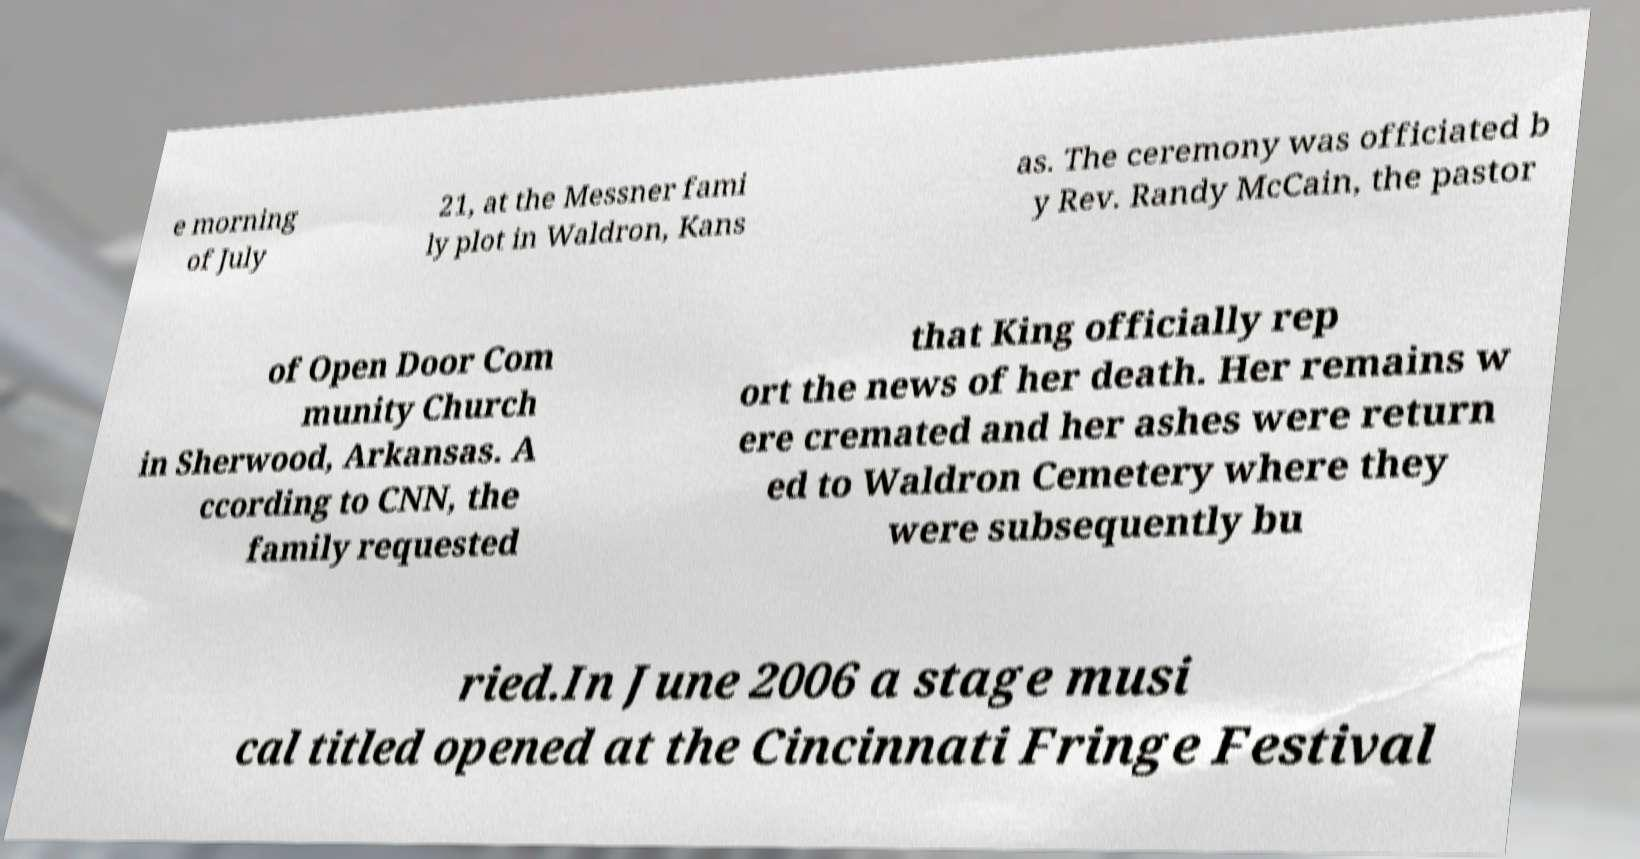Can you accurately transcribe the text from the provided image for me? e morning of July 21, at the Messner fami ly plot in Waldron, Kans as. The ceremony was officiated b y Rev. Randy McCain, the pastor of Open Door Com munity Church in Sherwood, Arkansas. A ccording to CNN, the family requested that King officially rep ort the news of her death. Her remains w ere cremated and her ashes were return ed to Waldron Cemetery where they were subsequently bu ried.In June 2006 a stage musi cal titled opened at the Cincinnati Fringe Festival 